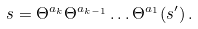Convert formula to latex. <formula><loc_0><loc_0><loc_500><loc_500>s = \Theta ^ { a _ { k } } \Theta ^ { a _ { k - 1 } } \dots \Theta ^ { a _ { 1 } } ( s ^ { \prime } ) \, .</formula> 